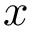<formula> <loc_0><loc_0><loc_500><loc_500>x</formula> 